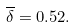Convert formula to latex. <formula><loc_0><loc_0><loc_500><loc_500>\overline { \delta } = 0 . 5 2 .</formula> 